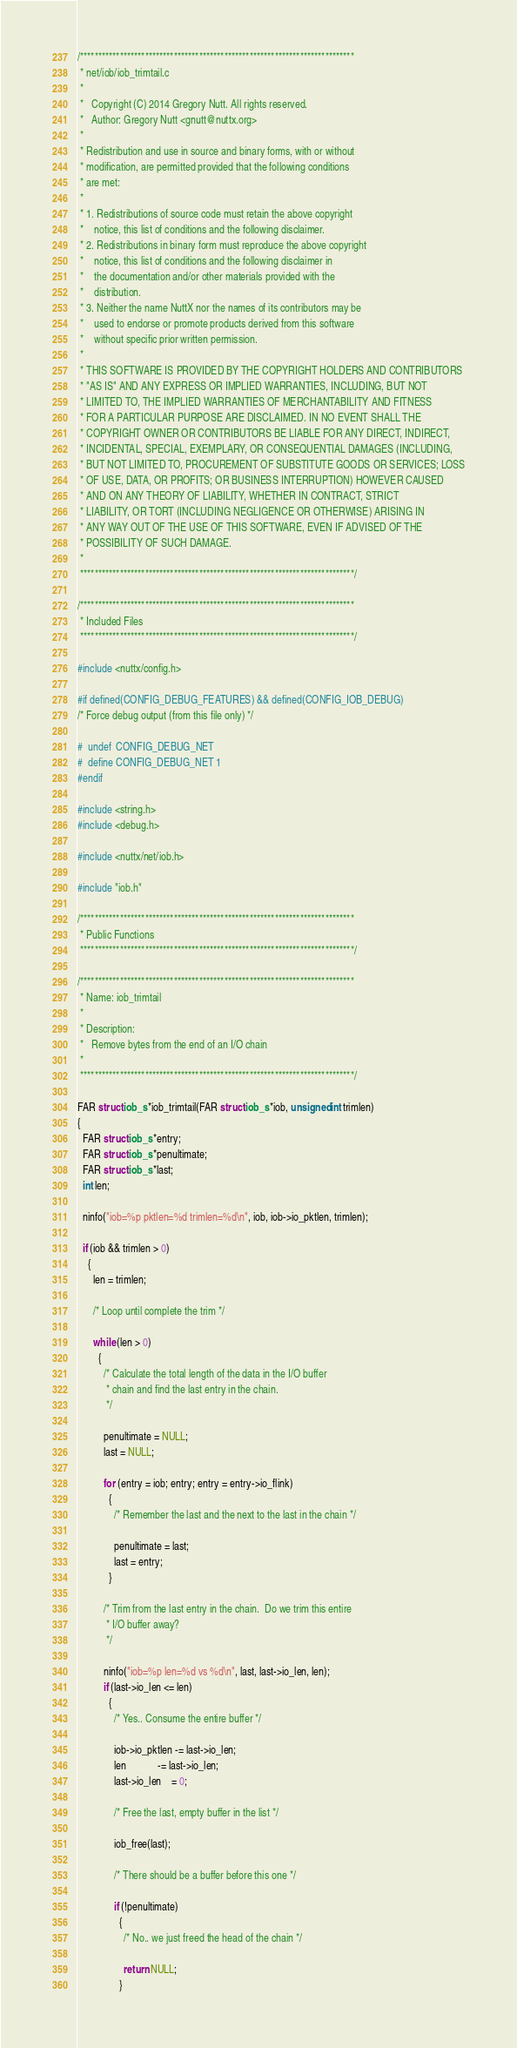Convert code to text. <code><loc_0><loc_0><loc_500><loc_500><_C_>/****************************************************************************
 * net/iob/iob_trimtail.c
 *
 *   Copyright (C) 2014 Gregory Nutt. All rights reserved.
 *   Author: Gregory Nutt <gnutt@nuttx.org>
 *
 * Redistribution and use in source and binary forms, with or without
 * modification, are permitted provided that the following conditions
 * are met:
 *
 * 1. Redistributions of source code must retain the above copyright
 *    notice, this list of conditions and the following disclaimer.
 * 2. Redistributions in binary form must reproduce the above copyright
 *    notice, this list of conditions and the following disclaimer in
 *    the documentation and/or other materials provided with the
 *    distribution.
 * 3. Neither the name NuttX nor the names of its contributors may be
 *    used to endorse or promote products derived from this software
 *    without specific prior written permission.
 *
 * THIS SOFTWARE IS PROVIDED BY THE COPYRIGHT HOLDERS AND CONTRIBUTORS
 * "AS IS" AND ANY EXPRESS OR IMPLIED WARRANTIES, INCLUDING, BUT NOT
 * LIMITED TO, THE IMPLIED WARRANTIES OF MERCHANTABILITY AND FITNESS
 * FOR A PARTICULAR PURPOSE ARE DISCLAIMED. IN NO EVENT SHALL THE
 * COPYRIGHT OWNER OR CONTRIBUTORS BE LIABLE FOR ANY DIRECT, INDIRECT,
 * INCIDENTAL, SPECIAL, EXEMPLARY, OR CONSEQUENTIAL DAMAGES (INCLUDING,
 * BUT NOT LIMITED TO, PROCUREMENT OF SUBSTITUTE GOODS OR SERVICES; LOSS
 * OF USE, DATA, OR PROFITS; OR BUSINESS INTERRUPTION) HOWEVER CAUSED
 * AND ON ANY THEORY OF LIABILITY, WHETHER IN CONTRACT, STRICT
 * LIABILITY, OR TORT (INCLUDING NEGLIGENCE OR OTHERWISE) ARISING IN
 * ANY WAY OUT OF THE USE OF THIS SOFTWARE, EVEN IF ADVISED OF THE
 * POSSIBILITY OF SUCH DAMAGE.
 *
 ****************************************************************************/

/****************************************************************************
 * Included Files
 ****************************************************************************/

#include <nuttx/config.h>

#if defined(CONFIG_DEBUG_FEATURES) && defined(CONFIG_IOB_DEBUG)
/* Force debug output (from this file only) */

#  undef  CONFIG_DEBUG_NET
#  define CONFIG_DEBUG_NET 1
#endif

#include <string.h>
#include <debug.h>

#include <nuttx/net/iob.h>

#include "iob.h"

/****************************************************************************
 * Public Functions
 ****************************************************************************/

/****************************************************************************
 * Name: iob_trimtail
 *
 * Description:
 *   Remove bytes from the end of an I/O chain
 *
 ****************************************************************************/

FAR struct iob_s *iob_trimtail(FAR struct iob_s *iob, unsigned int trimlen)
{
  FAR struct iob_s *entry;
  FAR struct iob_s *penultimate;
  FAR struct iob_s *last;
  int len;

  ninfo("iob=%p pktlen=%d trimlen=%d\n", iob, iob->io_pktlen, trimlen);

  if (iob && trimlen > 0)
    {
      len = trimlen;

      /* Loop until complete the trim */

      while (len > 0)
        {
          /* Calculate the total length of the data in the I/O buffer
           * chain and find the last entry in the chain.
           */

          penultimate = NULL;
          last = NULL;

          for (entry = iob; entry; entry = entry->io_flink)
            {
              /* Remember the last and the next to the last in the chain */

              penultimate = last;
              last = entry;
            }

          /* Trim from the last entry in the chain.  Do we trim this entire
           * I/O buffer away?
           */

          ninfo("iob=%p len=%d vs %d\n", last, last->io_len, len);
          if (last->io_len <= len)
            {
              /* Yes.. Consume the entire buffer */

              iob->io_pktlen -= last->io_len;
              len            -= last->io_len;
              last->io_len    = 0;

              /* Free the last, empty buffer in the list */

              iob_free(last);

              /* There should be a buffer before this one */

              if (!penultimate)
                {
                  /* No.. we just freed the head of the chain */

                  return NULL;
                }
</code> 